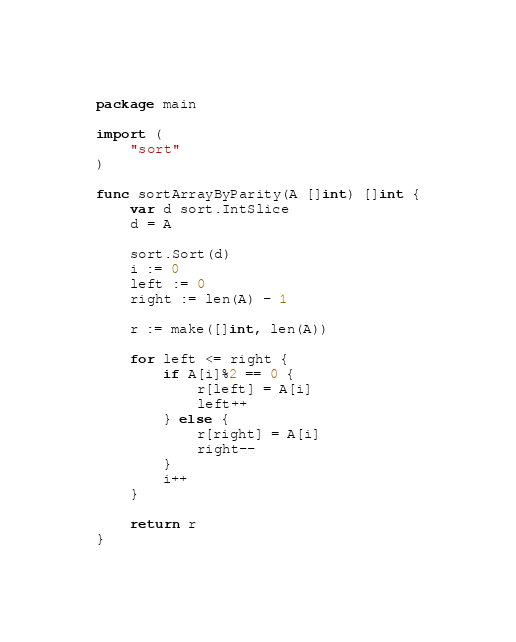<code> <loc_0><loc_0><loc_500><loc_500><_Go_>package main

import (
	"sort"
)

func sortArrayByParity(A []int) []int {
	var d sort.IntSlice
	d = A

	sort.Sort(d)
	i := 0
	left := 0
	right := len(A) - 1

	r := make([]int, len(A))

	for left <= right {
		if A[i]%2 == 0 {
			r[left] = A[i]
			left++
		} else {
			r[right] = A[i]
			right--
		}
		i++
	}

	return r
}
</code> 